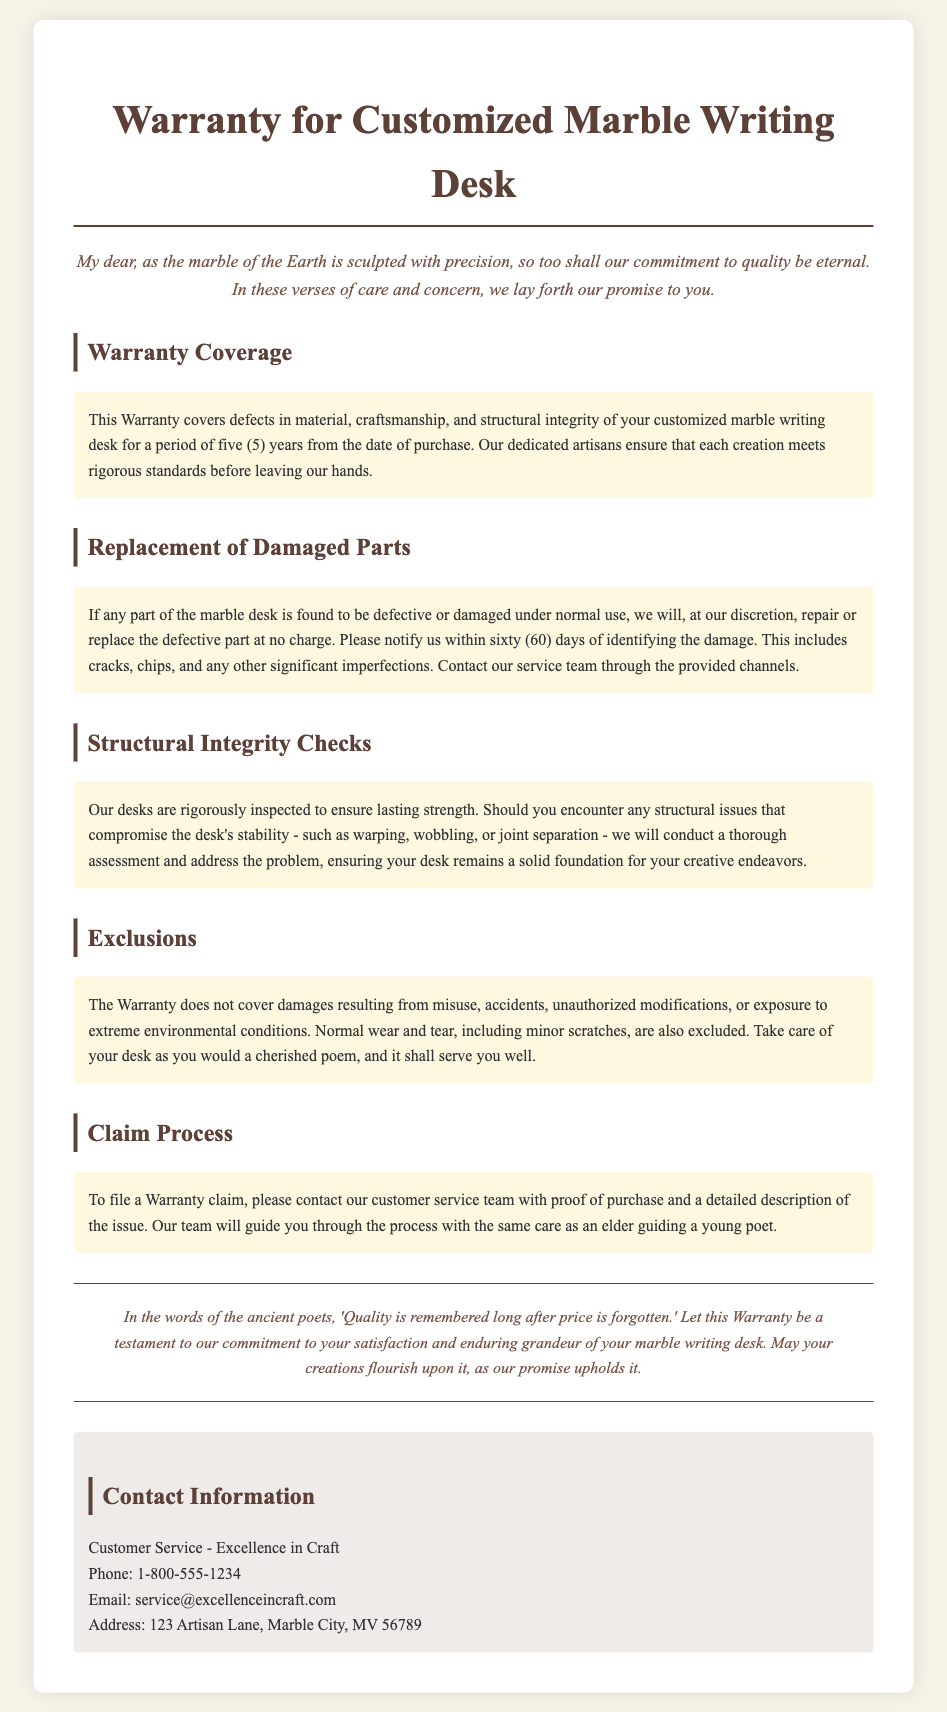What is the warranty period for the desk? The warranty period for the desk is five (5) years from the date of purchase.
Answer: five (5) years What type of issues does the warranty cover? The warranty covers defects in material, craftsmanship, and structural integrity.
Answer: defects in material, craftsmanship, and structural integrity How long do customers have to notify about damages? Customers must notify about damages within sixty (60) days of identifying the damage.
Answer: sixty (60) days What does the warranty not cover? The warranty does not cover damages resulting from misuse, accidents, unauthorized modifications, or exposure to extreme environmental conditions.
Answer: misuse, accidents, unauthorized modifications, extreme environmental conditions What will happen if structural issues occur? If structural issues occur, a thorough assessment will be conducted to address the problem.
Answer: a thorough assessment Who should you contact to file a warranty claim? Customers should contact the customer service team to file a warranty claim.
Answer: customer service team What is the phone number for customer service? The phone number for customer service is provided in the contact information section.
Answer: 1-800-555-1234 What is excluded in the warranty regarding desk appearance? Normal wear and tear, including minor scratches, is excluded from the warranty coverage.
Answer: normal wear and tear, minor scratches 